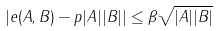Convert formula to latex. <formula><loc_0><loc_0><loc_500><loc_500>\left | e ( A , B ) - p | A | | B | \right | \leq \beta \sqrt { | A | | B | }</formula> 